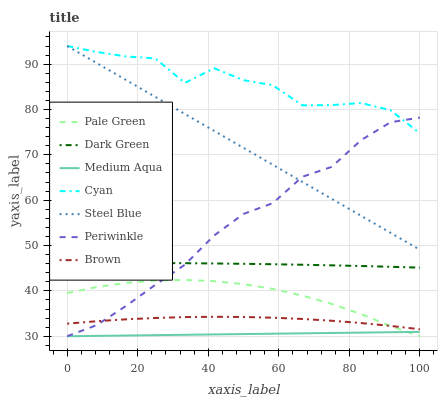Does Medium Aqua have the minimum area under the curve?
Answer yes or no. Yes. Does Cyan have the maximum area under the curve?
Answer yes or no. Yes. Does Brown have the minimum area under the curve?
Answer yes or no. No. Does Brown have the maximum area under the curve?
Answer yes or no. No. Is Medium Aqua the smoothest?
Answer yes or no. Yes. Is Cyan the roughest?
Answer yes or no. Yes. Is Brown the smoothest?
Answer yes or no. No. Is Brown the roughest?
Answer yes or no. No. Does Brown have the lowest value?
Answer yes or no. No. Does Cyan have the highest value?
Answer yes or no. Yes. Does Brown have the highest value?
Answer yes or no. No. Is Medium Aqua less than Dark Green?
Answer yes or no. Yes. Is Cyan greater than Pale Green?
Answer yes or no. Yes. Does Medium Aqua intersect Dark Green?
Answer yes or no. No. 